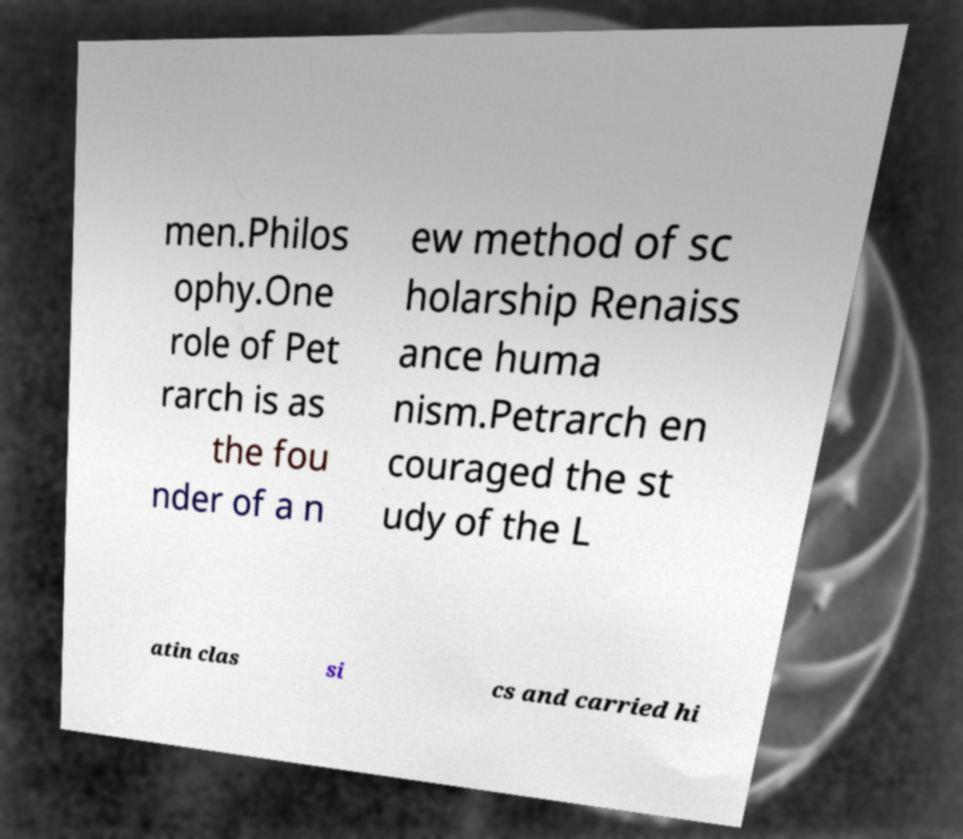Could you extract and type out the text from this image? men.Philos ophy.One role of Pet rarch is as the fou nder of a n ew method of sc holarship Renaiss ance huma nism.Petrarch en couraged the st udy of the L atin clas si cs and carried hi 